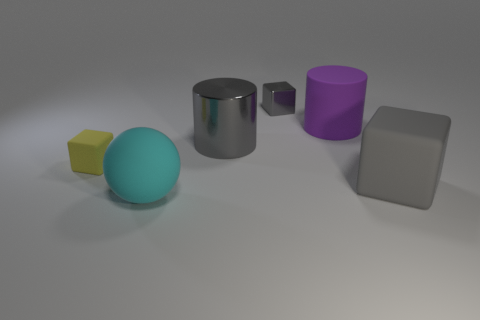Add 4 red matte cylinders. How many objects exist? 10 Subtract all cylinders. How many objects are left? 4 Subtract all tiny shiny blocks. Subtract all gray matte things. How many objects are left? 4 Add 1 small gray things. How many small gray things are left? 2 Add 4 gray blocks. How many gray blocks exist? 6 Subtract 0 cyan cubes. How many objects are left? 6 